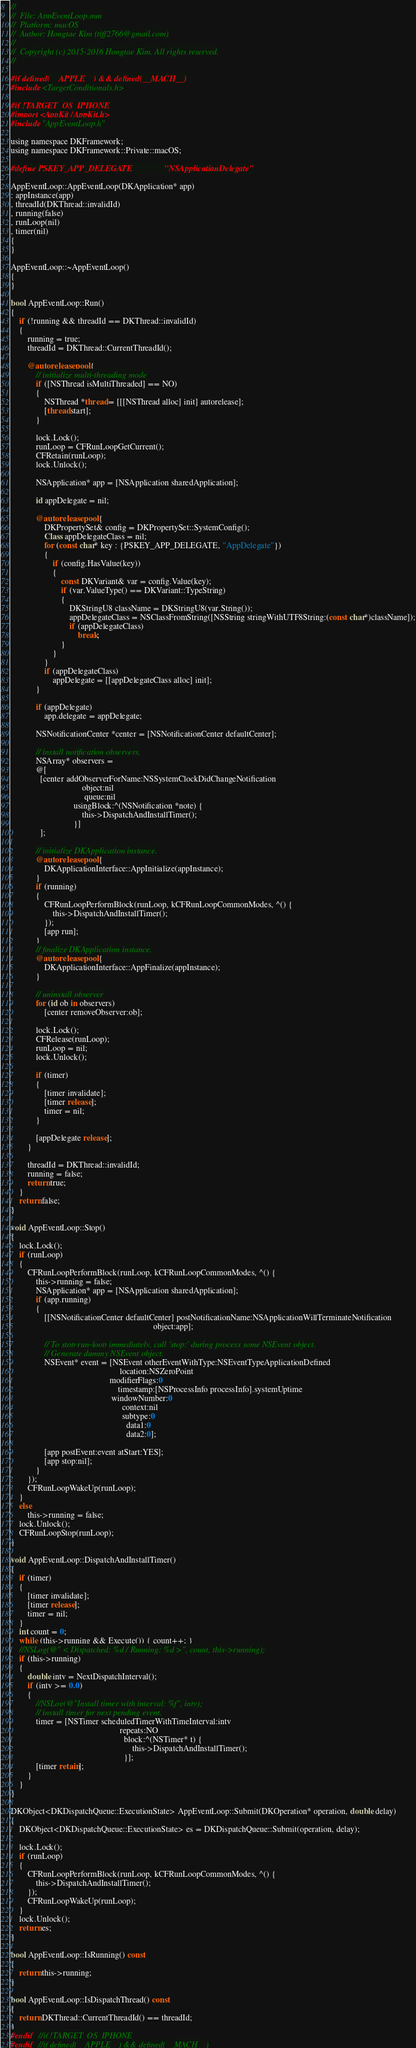Convert code to text. <code><loc_0><loc_0><loc_500><loc_500><_ObjectiveC_>//
//  File: AppEventLoop.mm
//  Platform: macOS
//  Author: Hongtae Kim (tiff2766@gmail.com)
//
//  Copyright (c) 2015-2016 Hongtae Kim. All rights reserved.
//

#if defined(__APPLE__) && defined(__MACH__)
#include <TargetConditionals.h>

#if !TARGET_OS_IPHONE
#import <AppKit/AppKit.h>
#include "AppEventLoop.h"

using namespace DKFramework;
using namespace DKFramework::Private::macOS;

#define PSKEY_APP_DELEGATE				"NSApplicationDelegate"

AppEventLoop::AppEventLoop(DKApplication* app)
: appInstance(app)
, threadId(DKThread::invalidId)
, running(false)
, runLoop(nil)
, timer(nil)
{
}

AppEventLoop::~AppEventLoop()
{
}

bool AppEventLoop::Run()
{
	if (!running && threadId == DKThread::invalidId)
	{
		running = true;
        threadId = DKThread::CurrentThreadId();

		@autoreleasepool {
			// initialize multi-threading mode
			if ([NSThread isMultiThreaded] == NO)
			{
				NSThread *thread = [[[NSThread alloc] init] autorelease];
				[thread start];
			}

			lock.Lock();
			runLoop = CFRunLoopGetCurrent();
			CFRetain(runLoop);
			lock.Unlock();

			NSApplication* app = [NSApplication sharedApplication];

			id appDelegate = nil;

			@autoreleasepool {
				DKPropertySet& config = DKPropertySet::SystemConfig();
				Class appDelegateClass = nil;
				for (const char* key : {PSKEY_APP_DELEGATE, "AppDelegate"})
				{
					if (config.HasValue(key))
					{
						const DKVariant& var = config.Value(key);
						if (var.ValueType() == DKVariant::TypeString)
						{
							DKStringU8 className = DKStringU8(var.String());
							appDelegateClass = NSClassFromString([NSString stringWithUTF8String:(const char*)className]);
							if (appDelegateClass)
								break;
						}
					}
				}
				if (appDelegateClass)
					appDelegate = [[appDelegateClass alloc] init];
			}

			if (appDelegate)
				app.delegate = appDelegate;

			NSNotificationCenter *center = [NSNotificationCenter defaultCenter];

			// install notification observers.
			NSArray* observers =
			@[
			  [center addObserverForName:NSSystemClockDidChangeNotification
								  object:nil
								   queue:nil
							  usingBlock:^(NSNotification *note) {
								  this->DispatchAndInstallTimer();
							  }]
			  ];

			// initialize DKApplication instance.
			@autoreleasepool {
				DKApplicationInterface::AppInitialize(appInstance);
			}
			if (running)
			{
				CFRunLoopPerformBlock(runLoop, kCFRunLoopCommonModes, ^() {
					this->DispatchAndInstallTimer();
				});
				[app run];
			}
			// finalize DKApplication instance.
			@autoreleasepool {
				DKApplicationInterface::AppFinalize(appInstance);
			}

			// uninstall observer
			for (id ob in observers)
				[center removeObserver:ob];

			lock.Lock();
			CFRelease(runLoop);
			runLoop = nil;
			lock.Unlock();

			if (timer)
			{
				[timer invalidate];
				[timer release];
				timer = nil;
			}
			
			[appDelegate release];
		}

        threadId = DKThread::invalidId;
		running = false;
		return true;
	}
	return false;
}

void AppEventLoop::Stop()
{
	lock.Lock();
	if (runLoop)
	{
		CFRunLoopPerformBlock(runLoop, kCFRunLoopCommonModes, ^() {
			this->running = false;
			NSApplication* app = [NSApplication sharedApplication];
			if (app.running)
			{
				[[NSNotificationCenter defaultCenter] postNotificationName:NSApplicationWillTerminateNotification
																	object:app];

				// To stop run-loop immediately, call 'stop:' during process some NSEvent object.
				// Generate dummy NSEvent object.
				NSEvent* event = [NSEvent otherEventWithType:NSEventTypeApplicationDefined
													location:NSZeroPoint
											   modifierFlags:0
												   timestamp:[NSProcessInfo processInfo].systemUptime
												windowNumber:0
													 context:nil
													 subtype:0
													   data1:0
													   data2:0];

				[app postEvent:event atStart:YES];
				[app stop:nil];
			}
		});
		CFRunLoopWakeUp(runLoop);
	}
	else
		this->running = false;
	lock.Unlock();
	CFRunLoopStop(runLoop);
}

void AppEventLoop::DispatchAndInstallTimer()
{
	if (timer)
	{
		[timer invalidate];
		[timer release];
		timer = nil;
	}
	int count = 0;
	while (this->running && Execute()) { count++; }
	//NSLog(@" < Dispatched: %d / Running: %d >", count, this->running);
	if (this->running)
	{
		double intv = NextDispatchInterval();
		if (intv >= 0.0)
		{
			//NSLog(@"Install timer with interval: %f", intv);
			// install timer for next pending event.
			timer = [NSTimer scheduledTimerWithTimeInterval:intv
													repeats:NO
													  block:^(NSTimer* t) {
														  this->DispatchAndInstallTimer();
													  }];
			[timer retain];
		}
	}
}

DKObject<DKDispatchQueue::ExecutionState> AppEventLoop::Submit(DKOperation* operation, double delay)
{
	DKObject<DKDispatchQueue::ExecutionState> es = DKDispatchQueue::Submit(operation, delay);

	lock.Lock();
	if (runLoop)
	{
		CFRunLoopPerformBlock(runLoop, kCFRunLoopCommonModes, ^() {
			this->DispatchAndInstallTimer();
		});
		CFRunLoopWakeUp(runLoop);
	}
	lock.Unlock();
	return es;
}

bool AppEventLoop::IsRunning() const
{
    return this->running;
}

bool AppEventLoop::IsDispatchThread() const
{
    return DKThread::CurrentThreadId() == threadId;
}
#endif	//if !TARGET_OS_IPHONE
#endif	//if defined(__APPLE__) && defined(__MACH__)
</code> 